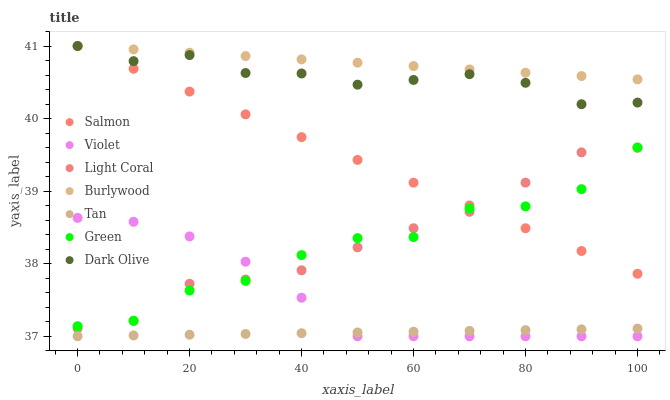Does Tan have the minimum area under the curve?
Answer yes or no. Yes. Does Burlywood have the maximum area under the curve?
Answer yes or no. Yes. Does Dark Olive have the minimum area under the curve?
Answer yes or no. No. Does Dark Olive have the maximum area under the curve?
Answer yes or no. No. Is Salmon the smoothest?
Answer yes or no. Yes. Is Green the roughest?
Answer yes or no. Yes. Is Dark Olive the smoothest?
Answer yes or no. No. Is Dark Olive the roughest?
Answer yes or no. No. Does Violet have the lowest value?
Answer yes or no. Yes. Does Dark Olive have the lowest value?
Answer yes or no. No. Does Salmon have the highest value?
Answer yes or no. Yes. Does Light Coral have the highest value?
Answer yes or no. No. Is Green less than Burlywood?
Answer yes or no. Yes. Is Green greater than Tan?
Answer yes or no. Yes. Does Salmon intersect Green?
Answer yes or no. Yes. Is Salmon less than Green?
Answer yes or no. No. Is Salmon greater than Green?
Answer yes or no. No. Does Green intersect Burlywood?
Answer yes or no. No. 